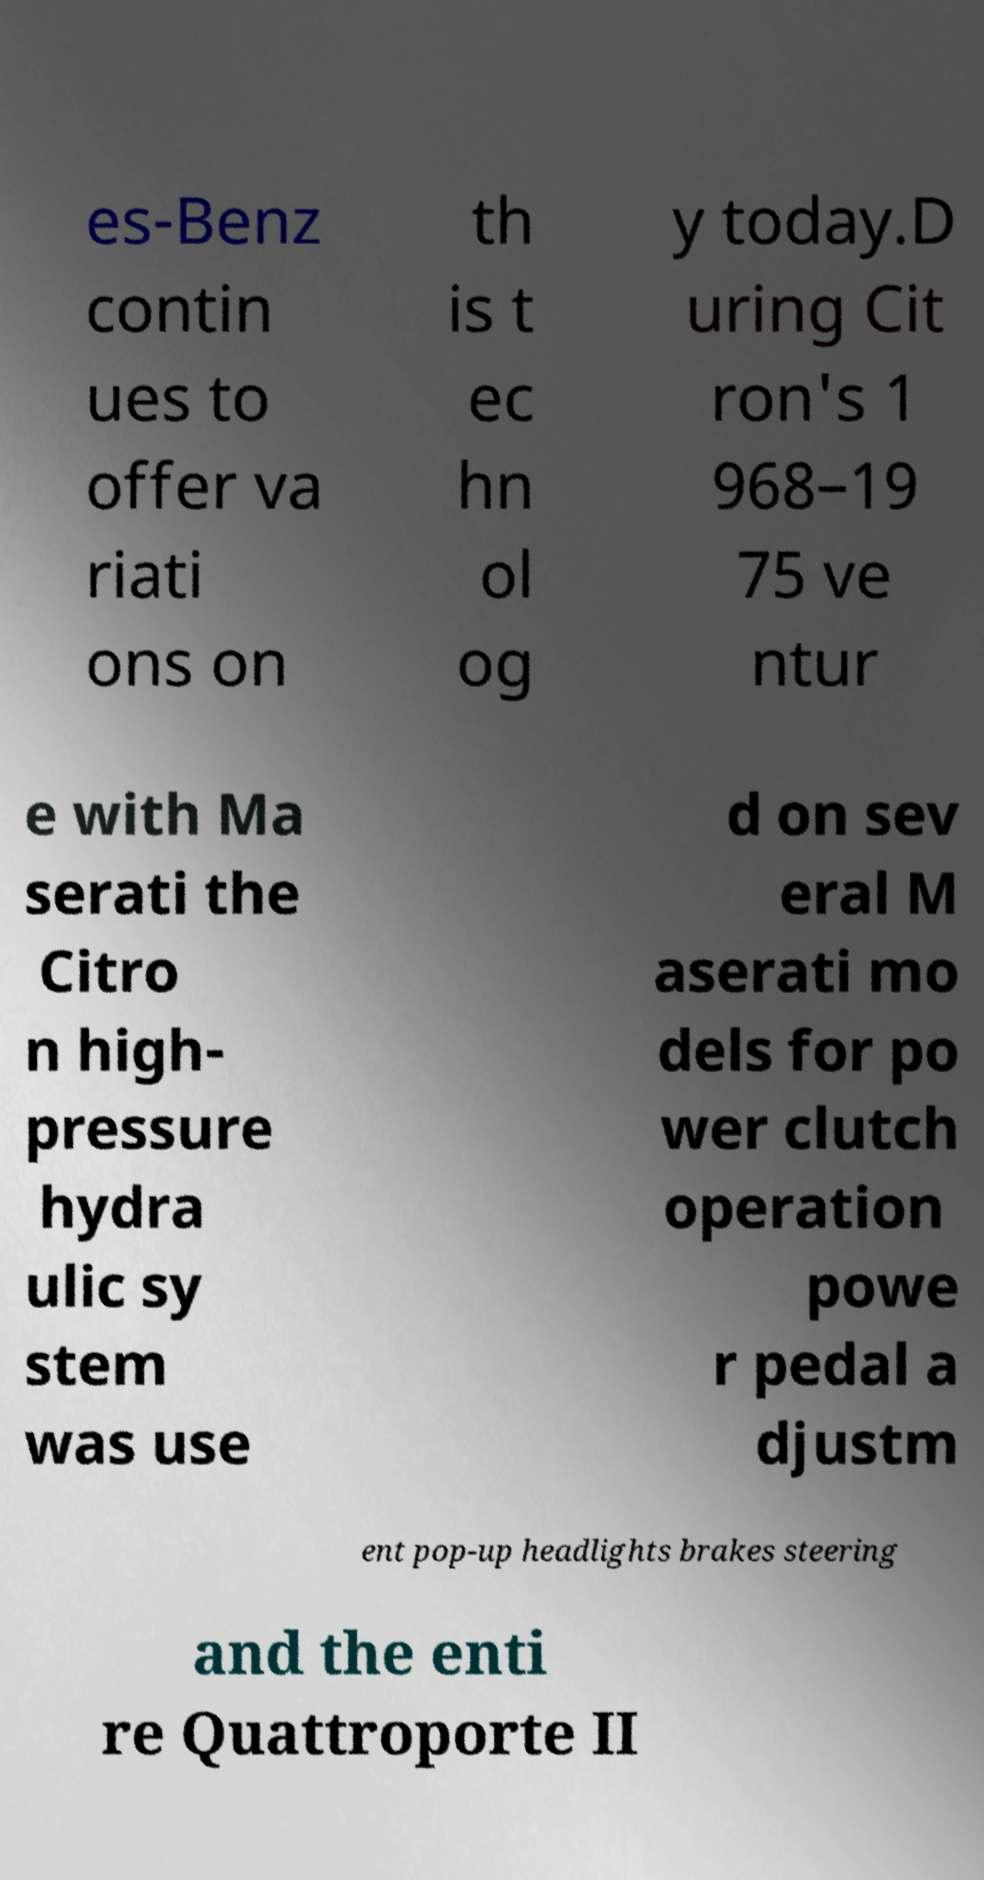Could you extract and type out the text from this image? es-Benz contin ues to offer va riati ons on th is t ec hn ol og y today.D uring Cit ron's 1 968–19 75 ve ntur e with Ma serati the Citro n high- pressure hydra ulic sy stem was use d on sev eral M aserati mo dels for po wer clutch operation powe r pedal a djustm ent pop-up headlights brakes steering and the enti re Quattroporte II 